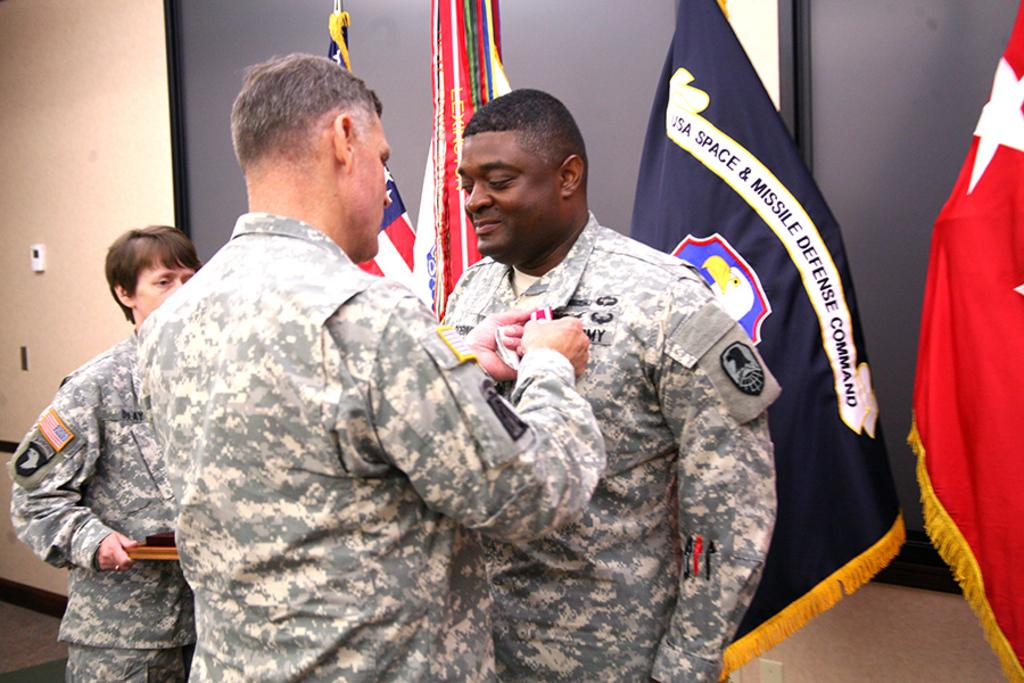<image>
Describe the image concisely. USA Space and Missile Defense Command is embroidered on the flag in the background. 